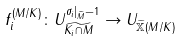Convert formula to latex. <formula><loc_0><loc_0><loc_500><loc_500>f _ { i } ^ { ( M / K ) } \colon U _ { \widetilde { K _ { i } \cap M } } ^ { \sigma _ { i } | _ { \widetilde { M } } - 1 } \rightarrow U _ { \widetilde { \mathbb { X } } ( M / K ) }</formula> 